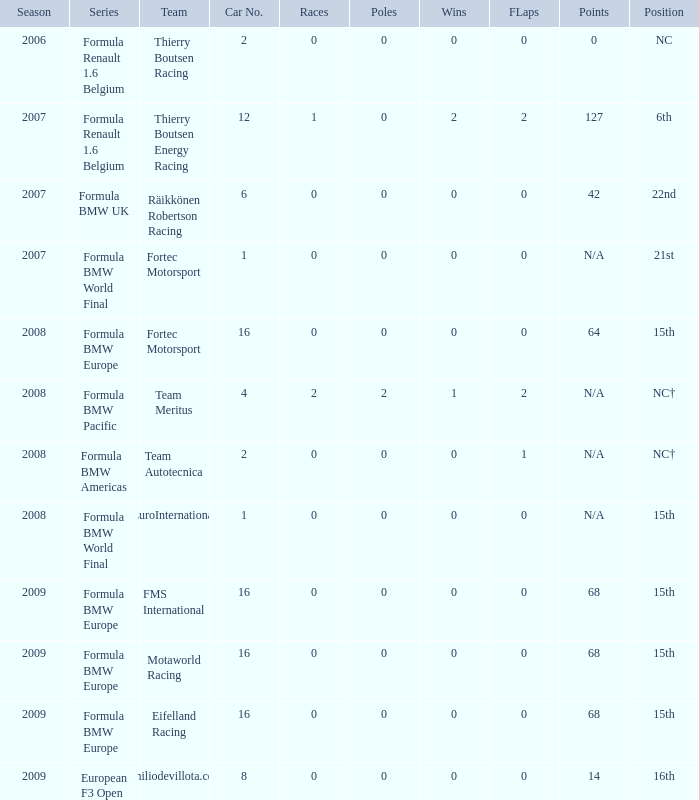Can you provide the points for the fourth car? N/A. 